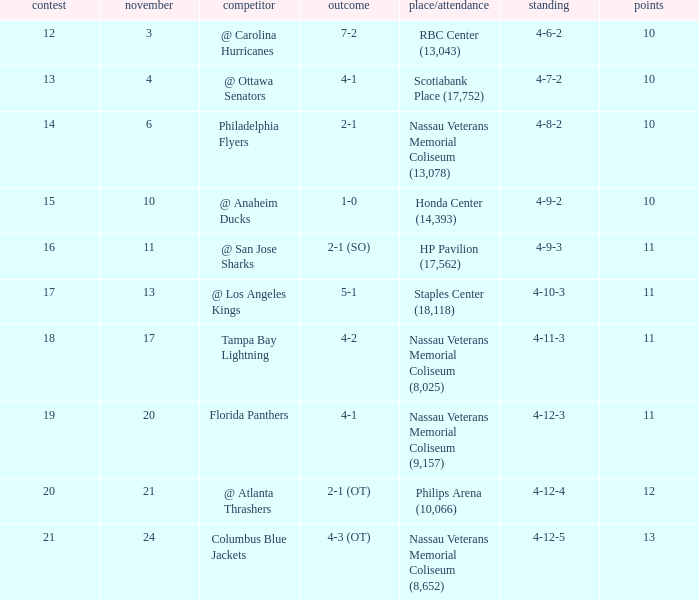I'm looking to parse the entire table for insights. Could you assist me with that? {'header': ['contest', 'november', 'competitor', 'outcome', 'place/attendance', 'standing', 'points'], 'rows': [['12', '3', '@ Carolina Hurricanes', '7-2', 'RBC Center (13,043)', '4-6-2', '10'], ['13', '4', '@ Ottawa Senators', '4-1', 'Scotiabank Place (17,752)', '4-7-2', '10'], ['14', '6', 'Philadelphia Flyers', '2-1', 'Nassau Veterans Memorial Coliseum (13,078)', '4-8-2', '10'], ['15', '10', '@ Anaheim Ducks', '1-0', 'Honda Center (14,393)', '4-9-2', '10'], ['16', '11', '@ San Jose Sharks', '2-1 (SO)', 'HP Pavilion (17,562)', '4-9-3', '11'], ['17', '13', '@ Los Angeles Kings', '5-1', 'Staples Center (18,118)', '4-10-3', '11'], ['18', '17', 'Tampa Bay Lightning', '4-2', 'Nassau Veterans Memorial Coliseum (8,025)', '4-11-3', '11'], ['19', '20', 'Florida Panthers', '4-1', 'Nassau Veterans Memorial Coliseum (9,157)', '4-12-3', '11'], ['20', '21', '@ Atlanta Thrashers', '2-1 (OT)', 'Philips Arena (10,066)', '4-12-4', '12'], ['21', '24', 'Columbus Blue Jackets', '4-3 (OT)', 'Nassau Veterans Memorial Coliseum (8,652)', '4-12-5', '13']]} What's the largest sum of points possible? 13.0. 